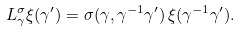Convert formula to latex. <formula><loc_0><loc_0><loc_500><loc_500>L ^ { \sigma } _ { \gamma } \xi ( \gamma ^ { \prime } ) = \sigma ( \gamma , \gamma ^ { - 1 } \gamma ^ { \prime } ) \, \xi ( \gamma ^ { - 1 } \gamma ^ { \prime } ) .</formula> 